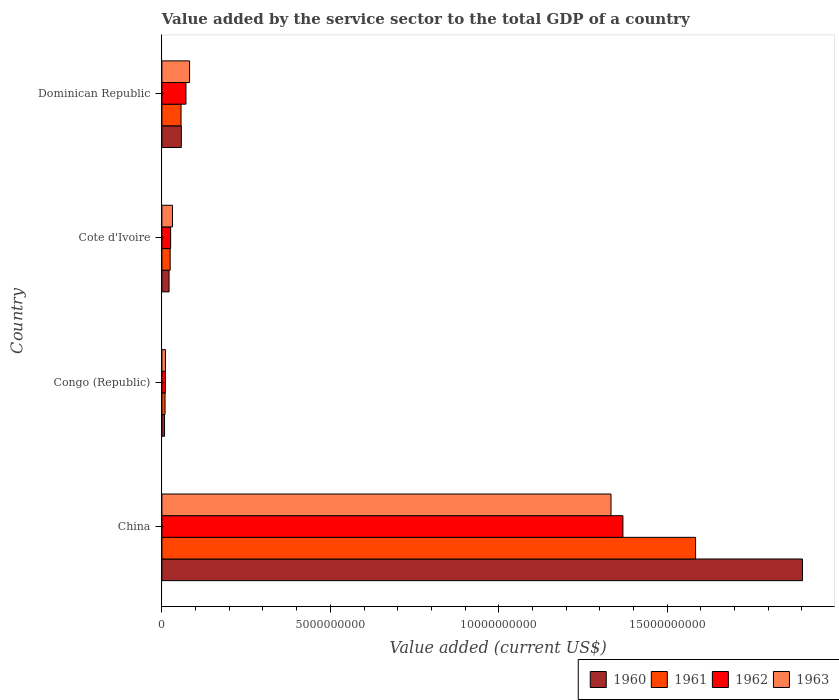How many different coloured bars are there?
Provide a short and direct response. 4. How many bars are there on the 3rd tick from the bottom?
Your answer should be very brief. 4. What is the label of the 3rd group of bars from the top?
Make the answer very short. Congo (Republic). What is the value added by the service sector to the total GDP in 1963 in Cote d'Ivoire?
Keep it short and to the point. 3.13e+08. Across all countries, what is the maximum value added by the service sector to the total GDP in 1960?
Your answer should be very brief. 1.90e+1. Across all countries, what is the minimum value added by the service sector to the total GDP in 1960?
Offer a terse response. 7.82e+07. In which country was the value added by the service sector to the total GDP in 1962 minimum?
Offer a terse response. Congo (Republic). What is the total value added by the service sector to the total GDP in 1962 in the graph?
Ensure brevity in your answer.  1.48e+1. What is the difference between the value added by the service sector to the total GDP in 1961 in Cote d'Ivoire and that in Dominican Republic?
Provide a short and direct response. -3.23e+08. What is the difference between the value added by the service sector to the total GDP in 1963 in Cote d'Ivoire and the value added by the service sector to the total GDP in 1961 in China?
Offer a very short reply. -1.55e+1. What is the average value added by the service sector to the total GDP in 1963 per country?
Offer a terse response. 3.64e+09. What is the difference between the value added by the service sector to the total GDP in 1963 and value added by the service sector to the total GDP in 1960 in China?
Keep it short and to the point. -5.68e+09. What is the ratio of the value added by the service sector to the total GDP in 1962 in Congo (Republic) to that in Dominican Republic?
Keep it short and to the point. 0.15. Is the value added by the service sector to the total GDP in 1962 in Cote d'Ivoire less than that in Dominican Republic?
Your answer should be very brief. Yes. What is the difference between the highest and the second highest value added by the service sector to the total GDP in 1963?
Keep it short and to the point. 1.25e+1. What is the difference between the highest and the lowest value added by the service sector to the total GDP in 1962?
Your answer should be very brief. 1.36e+1. Is the sum of the value added by the service sector to the total GDP in 1961 in Congo (Republic) and Cote d'Ivoire greater than the maximum value added by the service sector to the total GDP in 1962 across all countries?
Make the answer very short. No. Is it the case that in every country, the sum of the value added by the service sector to the total GDP in 1960 and value added by the service sector to the total GDP in 1963 is greater than the sum of value added by the service sector to the total GDP in 1961 and value added by the service sector to the total GDP in 1962?
Your answer should be very brief. No. What does the 2nd bar from the top in Dominican Republic represents?
Make the answer very short. 1962. What does the 2nd bar from the bottom in China represents?
Your answer should be very brief. 1961. Are all the bars in the graph horizontal?
Provide a short and direct response. Yes. How many countries are there in the graph?
Your answer should be very brief. 4. Are the values on the major ticks of X-axis written in scientific E-notation?
Make the answer very short. No. Does the graph contain grids?
Ensure brevity in your answer.  No. Where does the legend appear in the graph?
Your answer should be very brief. Bottom right. How many legend labels are there?
Make the answer very short. 4. How are the legend labels stacked?
Your answer should be very brief. Horizontal. What is the title of the graph?
Your answer should be compact. Value added by the service sector to the total GDP of a country. Does "2007" appear as one of the legend labels in the graph?
Offer a very short reply. No. What is the label or title of the X-axis?
Keep it short and to the point. Value added (current US$). What is the label or title of the Y-axis?
Provide a short and direct response. Country. What is the Value added (current US$) in 1960 in China?
Offer a very short reply. 1.90e+1. What is the Value added (current US$) of 1961 in China?
Your answer should be very brief. 1.58e+1. What is the Value added (current US$) of 1962 in China?
Your response must be concise. 1.37e+1. What is the Value added (current US$) of 1963 in China?
Offer a terse response. 1.33e+1. What is the Value added (current US$) of 1960 in Congo (Republic)?
Provide a succinct answer. 7.82e+07. What is the Value added (current US$) in 1961 in Congo (Republic)?
Your response must be concise. 9.33e+07. What is the Value added (current US$) in 1962 in Congo (Republic)?
Provide a succinct answer. 1.04e+08. What is the Value added (current US$) in 1963 in Congo (Republic)?
Your answer should be compact. 1.06e+08. What is the Value added (current US$) of 1960 in Cote d'Ivoire?
Provide a succinct answer. 2.13e+08. What is the Value added (current US$) in 1961 in Cote d'Ivoire?
Provide a short and direct response. 2.46e+08. What is the Value added (current US$) of 1962 in Cote d'Ivoire?
Give a very brief answer. 2.59e+08. What is the Value added (current US$) of 1963 in Cote d'Ivoire?
Offer a very short reply. 3.13e+08. What is the Value added (current US$) of 1960 in Dominican Republic?
Offer a terse response. 5.76e+08. What is the Value added (current US$) in 1961 in Dominican Republic?
Provide a short and direct response. 5.68e+08. What is the Value added (current US$) in 1962 in Dominican Republic?
Your response must be concise. 7.14e+08. What is the Value added (current US$) in 1963 in Dominican Republic?
Keep it short and to the point. 8.22e+08. Across all countries, what is the maximum Value added (current US$) of 1960?
Provide a short and direct response. 1.90e+1. Across all countries, what is the maximum Value added (current US$) in 1961?
Offer a terse response. 1.58e+1. Across all countries, what is the maximum Value added (current US$) in 1962?
Your response must be concise. 1.37e+1. Across all countries, what is the maximum Value added (current US$) in 1963?
Your answer should be very brief. 1.33e+1. Across all countries, what is the minimum Value added (current US$) in 1960?
Your response must be concise. 7.82e+07. Across all countries, what is the minimum Value added (current US$) in 1961?
Offer a very short reply. 9.33e+07. Across all countries, what is the minimum Value added (current US$) of 1962?
Provide a short and direct response. 1.04e+08. Across all countries, what is the minimum Value added (current US$) of 1963?
Offer a very short reply. 1.06e+08. What is the total Value added (current US$) of 1960 in the graph?
Offer a terse response. 1.99e+1. What is the total Value added (current US$) of 1961 in the graph?
Offer a terse response. 1.67e+1. What is the total Value added (current US$) in 1962 in the graph?
Make the answer very short. 1.48e+1. What is the total Value added (current US$) in 1963 in the graph?
Your answer should be compact. 1.46e+1. What is the difference between the Value added (current US$) of 1960 in China and that in Congo (Republic)?
Provide a succinct answer. 1.89e+1. What is the difference between the Value added (current US$) in 1961 in China and that in Congo (Republic)?
Provide a succinct answer. 1.57e+1. What is the difference between the Value added (current US$) in 1962 in China and that in Congo (Republic)?
Your answer should be compact. 1.36e+1. What is the difference between the Value added (current US$) of 1963 in China and that in Congo (Republic)?
Ensure brevity in your answer.  1.32e+1. What is the difference between the Value added (current US$) of 1960 in China and that in Cote d'Ivoire?
Your response must be concise. 1.88e+1. What is the difference between the Value added (current US$) in 1961 in China and that in Cote d'Ivoire?
Your response must be concise. 1.56e+1. What is the difference between the Value added (current US$) in 1962 in China and that in Cote d'Ivoire?
Give a very brief answer. 1.34e+1. What is the difference between the Value added (current US$) in 1963 in China and that in Cote d'Ivoire?
Offer a very short reply. 1.30e+1. What is the difference between the Value added (current US$) of 1960 in China and that in Dominican Republic?
Your response must be concise. 1.84e+1. What is the difference between the Value added (current US$) in 1961 in China and that in Dominican Republic?
Ensure brevity in your answer.  1.53e+1. What is the difference between the Value added (current US$) of 1962 in China and that in Dominican Republic?
Your response must be concise. 1.30e+1. What is the difference between the Value added (current US$) in 1963 in China and that in Dominican Republic?
Your response must be concise. 1.25e+1. What is the difference between the Value added (current US$) of 1960 in Congo (Republic) and that in Cote d'Ivoire?
Give a very brief answer. -1.35e+08. What is the difference between the Value added (current US$) of 1961 in Congo (Republic) and that in Cote d'Ivoire?
Provide a succinct answer. -1.52e+08. What is the difference between the Value added (current US$) in 1962 in Congo (Republic) and that in Cote d'Ivoire?
Provide a short and direct response. -1.55e+08. What is the difference between the Value added (current US$) in 1963 in Congo (Republic) and that in Cote d'Ivoire?
Keep it short and to the point. -2.08e+08. What is the difference between the Value added (current US$) in 1960 in Congo (Republic) and that in Dominican Republic?
Offer a terse response. -4.98e+08. What is the difference between the Value added (current US$) of 1961 in Congo (Republic) and that in Dominican Republic?
Provide a succinct answer. -4.75e+08. What is the difference between the Value added (current US$) in 1962 in Congo (Republic) and that in Dominican Republic?
Offer a terse response. -6.11e+08. What is the difference between the Value added (current US$) in 1963 in Congo (Republic) and that in Dominican Republic?
Offer a very short reply. -7.16e+08. What is the difference between the Value added (current US$) in 1960 in Cote d'Ivoire and that in Dominican Republic?
Keep it short and to the point. -3.63e+08. What is the difference between the Value added (current US$) of 1961 in Cote d'Ivoire and that in Dominican Republic?
Give a very brief answer. -3.23e+08. What is the difference between the Value added (current US$) in 1962 in Cote d'Ivoire and that in Dominican Republic?
Your response must be concise. -4.56e+08. What is the difference between the Value added (current US$) of 1963 in Cote d'Ivoire and that in Dominican Republic?
Provide a short and direct response. -5.09e+08. What is the difference between the Value added (current US$) in 1960 in China and the Value added (current US$) in 1961 in Congo (Republic)?
Your response must be concise. 1.89e+1. What is the difference between the Value added (current US$) in 1960 in China and the Value added (current US$) in 1962 in Congo (Republic)?
Offer a terse response. 1.89e+1. What is the difference between the Value added (current US$) of 1960 in China and the Value added (current US$) of 1963 in Congo (Republic)?
Offer a terse response. 1.89e+1. What is the difference between the Value added (current US$) of 1961 in China and the Value added (current US$) of 1962 in Congo (Republic)?
Your response must be concise. 1.57e+1. What is the difference between the Value added (current US$) in 1961 in China and the Value added (current US$) in 1963 in Congo (Republic)?
Your response must be concise. 1.57e+1. What is the difference between the Value added (current US$) of 1962 in China and the Value added (current US$) of 1963 in Congo (Republic)?
Ensure brevity in your answer.  1.36e+1. What is the difference between the Value added (current US$) of 1960 in China and the Value added (current US$) of 1961 in Cote d'Ivoire?
Your response must be concise. 1.88e+1. What is the difference between the Value added (current US$) of 1960 in China and the Value added (current US$) of 1962 in Cote d'Ivoire?
Give a very brief answer. 1.88e+1. What is the difference between the Value added (current US$) of 1960 in China and the Value added (current US$) of 1963 in Cote d'Ivoire?
Keep it short and to the point. 1.87e+1. What is the difference between the Value added (current US$) of 1961 in China and the Value added (current US$) of 1962 in Cote d'Ivoire?
Keep it short and to the point. 1.56e+1. What is the difference between the Value added (current US$) in 1961 in China and the Value added (current US$) in 1963 in Cote d'Ivoire?
Ensure brevity in your answer.  1.55e+1. What is the difference between the Value added (current US$) of 1962 in China and the Value added (current US$) of 1963 in Cote d'Ivoire?
Your response must be concise. 1.34e+1. What is the difference between the Value added (current US$) of 1960 in China and the Value added (current US$) of 1961 in Dominican Republic?
Offer a very short reply. 1.84e+1. What is the difference between the Value added (current US$) of 1960 in China and the Value added (current US$) of 1962 in Dominican Republic?
Your answer should be compact. 1.83e+1. What is the difference between the Value added (current US$) of 1960 in China and the Value added (current US$) of 1963 in Dominican Republic?
Offer a very short reply. 1.82e+1. What is the difference between the Value added (current US$) in 1961 in China and the Value added (current US$) in 1962 in Dominican Republic?
Make the answer very short. 1.51e+1. What is the difference between the Value added (current US$) of 1961 in China and the Value added (current US$) of 1963 in Dominican Republic?
Your answer should be very brief. 1.50e+1. What is the difference between the Value added (current US$) in 1962 in China and the Value added (current US$) in 1963 in Dominican Republic?
Keep it short and to the point. 1.29e+1. What is the difference between the Value added (current US$) in 1960 in Congo (Republic) and the Value added (current US$) in 1961 in Cote d'Ivoire?
Ensure brevity in your answer.  -1.67e+08. What is the difference between the Value added (current US$) in 1960 in Congo (Republic) and the Value added (current US$) in 1962 in Cote d'Ivoire?
Your answer should be very brief. -1.81e+08. What is the difference between the Value added (current US$) in 1960 in Congo (Republic) and the Value added (current US$) in 1963 in Cote d'Ivoire?
Your answer should be very brief. -2.35e+08. What is the difference between the Value added (current US$) in 1961 in Congo (Republic) and the Value added (current US$) in 1962 in Cote d'Ivoire?
Ensure brevity in your answer.  -1.66e+08. What is the difference between the Value added (current US$) of 1961 in Congo (Republic) and the Value added (current US$) of 1963 in Cote d'Ivoire?
Your answer should be compact. -2.20e+08. What is the difference between the Value added (current US$) in 1962 in Congo (Republic) and the Value added (current US$) in 1963 in Cote d'Ivoire?
Give a very brief answer. -2.09e+08. What is the difference between the Value added (current US$) of 1960 in Congo (Republic) and the Value added (current US$) of 1961 in Dominican Republic?
Your answer should be compact. -4.90e+08. What is the difference between the Value added (current US$) of 1960 in Congo (Republic) and the Value added (current US$) of 1962 in Dominican Republic?
Your answer should be compact. -6.36e+08. What is the difference between the Value added (current US$) of 1960 in Congo (Republic) and the Value added (current US$) of 1963 in Dominican Republic?
Make the answer very short. -7.43e+08. What is the difference between the Value added (current US$) in 1961 in Congo (Republic) and the Value added (current US$) in 1962 in Dominican Republic?
Your response must be concise. -6.21e+08. What is the difference between the Value added (current US$) of 1961 in Congo (Republic) and the Value added (current US$) of 1963 in Dominican Republic?
Your answer should be very brief. -7.28e+08. What is the difference between the Value added (current US$) of 1962 in Congo (Republic) and the Value added (current US$) of 1963 in Dominican Republic?
Your response must be concise. -7.18e+08. What is the difference between the Value added (current US$) in 1960 in Cote d'Ivoire and the Value added (current US$) in 1961 in Dominican Republic?
Your answer should be compact. -3.56e+08. What is the difference between the Value added (current US$) in 1960 in Cote d'Ivoire and the Value added (current US$) in 1962 in Dominican Republic?
Offer a very short reply. -5.02e+08. What is the difference between the Value added (current US$) of 1960 in Cote d'Ivoire and the Value added (current US$) of 1963 in Dominican Republic?
Keep it short and to the point. -6.09e+08. What is the difference between the Value added (current US$) in 1961 in Cote d'Ivoire and the Value added (current US$) in 1962 in Dominican Republic?
Give a very brief answer. -4.69e+08. What is the difference between the Value added (current US$) in 1961 in Cote d'Ivoire and the Value added (current US$) in 1963 in Dominican Republic?
Your response must be concise. -5.76e+08. What is the difference between the Value added (current US$) of 1962 in Cote d'Ivoire and the Value added (current US$) of 1963 in Dominican Republic?
Provide a short and direct response. -5.63e+08. What is the average Value added (current US$) of 1960 per country?
Keep it short and to the point. 4.97e+09. What is the average Value added (current US$) in 1961 per country?
Give a very brief answer. 4.19e+09. What is the average Value added (current US$) in 1962 per country?
Offer a terse response. 3.69e+09. What is the average Value added (current US$) of 1963 per country?
Your answer should be very brief. 3.64e+09. What is the difference between the Value added (current US$) in 1960 and Value added (current US$) in 1961 in China?
Your answer should be very brief. 3.17e+09. What is the difference between the Value added (current US$) of 1960 and Value added (current US$) of 1962 in China?
Your response must be concise. 5.33e+09. What is the difference between the Value added (current US$) of 1960 and Value added (current US$) of 1963 in China?
Your answer should be compact. 5.68e+09. What is the difference between the Value added (current US$) in 1961 and Value added (current US$) in 1962 in China?
Ensure brevity in your answer.  2.16e+09. What is the difference between the Value added (current US$) of 1961 and Value added (current US$) of 1963 in China?
Keep it short and to the point. 2.51e+09. What is the difference between the Value added (current US$) in 1962 and Value added (current US$) in 1963 in China?
Provide a short and direct response. 3.53e+08. What is the difference between the Value added (current US$) in 1960 and Value added (current US$) in 1961 in Congo (Republic)?
Provide a short and direct response. -1.51e+07. What is the difference between the Value added (current US$) of 1960 and Value added (current US$) of 1962 in Congo (Republic)?
Your response must be concise. -2.55e+07. What is the difference between the Value added (current US$) in 1960 and Value added (current US$) in 1963 in Congo (Republic)?
Keep it short and to the point. -2.73e+07. What is the difference between the Value added (current US$) in 1961 and Value added (current US$) in 1962 in Congo (Republic)?
Make the answer very short. -1.05e+07. What is the difference between the Value added (current US$) in 1961 and Value added (current US$) in 1963 in Congo (Republic)?
Ensure brevity in your answer.  -1.23e+07. What is the difference between the Value added (current US$) of 1962 and Value added (current US$) of 1963 in Congo (Republic)?
Make the answer very short. -1.79e+06. What is the difference between the Value added (current US$) of 1960 and Value added (current US$) of 1961 in Cote d'Ivoire?
Provide a short and direct response. -3.28e+07. What is the difference between the Value added (current US$) of 1960 and Value added (current US$) of 1962 in Cote d'Ivoire?
Your answer should be very brief. -4.61e+07. What is the difference between the Value added (current US$) of 1960 and Value added (current US$) of 1963 in Cote d'Ivoire?
Keep it short and to the point. -1.00e+08. What is the difference between the Value added (current US$) of 1961 and Value added (current US$) of 1962 in Cote d'Ivoire?
Ensure brevity in your answer.  -1.33e+07. What is the difference between the Value added (current US$) in 1961 and Value added (current US$) in 1963 in Cote d'Ivoire?
Provide a short and direct response. -6.75e+07. What is the difference between the Value added (current US$) of 1962 and Value added (current US$) of 1963 in Cote d'Ivoire?
Make the answer very short. -5.42e+07. What is the difference between the Value added (current US$) in 1960 and Value added (current US$) in 1961 in Dominican Republic?
Your response must be concise. 7.50e+06. What is the difference between the Value added (current US$) of 1960 and Value added (current US$) of 1962 in Dominican Republic?
Your response must be concise. -1.39e+08. What is the difference between the Value added (current US$) of 1960 and Value added (current US$) of 1963 in Dominican Republic?
Keep it short and to the point. -2.46e+08. What is the difference between the Value added (current US$) of 1961 and Value added (current US$) of 1962 in Dominican Republic?
Your answer should be very brief. -1.46e+08. What is the difference between the Value added (current US$) of 1961 and Value added (current US$) of 1963 in Dominican Republic?
Give a very brief answer. -2.53e+08. What is the difference between the Value added (current US$) in 1962 and Value added (current US$) in 1963 in Dominican Republic?
Offer a terse response. -1.07e+08. What is the ratio of the Value added (current US$) of 1960 in China to that in Congo (Republic)?
Keep it short and to the point. 243.12. What is the ratio of the Value added (current US$) of 1961 in China to that in Congo (Republic)?
Ensure brevity in your answer.  169.84. What is the ratio of the Value added (current US$) of 1962 in China to that in Congo (Republic)?
Your answer should be very brief. 131.91. What is the ratio of the Value added (current US$) in 1963 in China to that in Congo (Republic)?
Make the answer very short. 126.33. What is the ratio of the Value added (current US$) in 1960 in China to that in Cote d'Ivoire?
Offer a very short reply. 89.37. What is the ratio of the Value added (current US$) of 1961 in China to that in Cote d'Ivoire?
Your response must be concise. 64.52. What is the ratio of the Value added (current US$) of 1962 in China to that in Cote d'Ivoire?
Your answer should be very brief. 52.87. What is the ratio of the Value added (current US$) in 1963 in China to that in Cote d'Ivoire?
Keep it short and to the point. 42.59. What is the ratio of the Value added (current US$) of 1960 in China to that in Dominican Republic?
Offer a terse response. 33.01. What is the ratio of the Value added (current US$) of 1961 in China to that in Dominican Republic?
Your answer should be very brief. 27.87. What is the ratio of the Value added (current US$) of 1962 in China to that in Dominican Republic?
Ensure brevity in your answer.  19.15. What is the ratio of the Value added (current US$) in 1963 in China to that in Dominican Republic?
Offer a terse response. 16.23. What is the ratio of the Value added (current US$) of 1960 in Congo (Republic) to that in Cote d'Ivoire?
Provide a succinct answer. 0.37. What is the ratio of the Value added (current US$) in 1961 in Congo (Republic) to that in Cote d'Ivoire?
Keep it short and to the point. 0.38. What is the ratio of the Value added (current US$) in 1962 in Congo (Republic) to that in Cote d'Ivoire?
Make the answer very short. 0.4. What is the ratio of the Value added (current US$) of 1963 in Congo (Republic) to that in Cote d'Ivoire?
Your answer should be compact. 0.34. What is the ratio of the Value added (current US$) of 1960 in Congo (Republic) to that in Dominican Republic?
Provide a short and direct response. 0.14. What is the ratio of the Value added (current US$) of 1961 in Congo (Republic) to that in Dominican Republic?
Your answer should be very brief. 0.16. What is the ratio of the Value added (current US$) in 1962 in Congo (Republic) to that in Dominican Republic?
Your answer should be very brief. 0.15. What is the ratio of the Value added (current US$) of 1963 in Congo (Republic) to that in Dominican Republic?
Offer a very short reply. 0.13. What is the ratio of the Value added (current US$) in 1960 in Cote d'Ivoire to that in Dominican Republic?
Offer a terse response. 0.37. What is the ratio of the Value added (current US$) in 1961 in Cote d'Ivoire to that in Dominican Republic?
Give a very brief answer. 0.43. What is the ratio of the Value added (current US$) of 1962 in Cote d'Ivoire to that in Dominican Republic?
Provide a short and direct response. 0.36. What is the ratio of the Value added (current US$) of 1963 in Cote d'Ivoire to that in Dominican Republic?
Your answer should be very brief. 0.38. What is the difference between the highest and the second highest Value added (current US$) in 1960?
Ensure brevity in your answer.  1.84e+1. What is the difference between the highest and the second highest Value added (current US$) in 1961?
Offer a terse response. 1.53e+1. What is the difference between the highest and the second highest Value added (current US$) in 1962?
Your response must be concise. 1.30e+1. What is the difference between the highest and the second highest Value added (current US$) of 1963?
Make the answer very short. 1.25e+1. What is the difference between the highest and the lowest Value added (current US$) of 1960?
Give a very brief answer. 1.89e+1. What is the difference between the highest and the lowest Value added (current US$) in 1961?
Your answer should be very brief. 1.57e+1. What is the difference between the highest and the lowest Value added (current US$) of 1962?
Offer a very short reply. 1.36e+1. What is the difference between the highest and the lowest Value added (current US$) in 1963?
Your answer should be compact. 1.32e+1. 